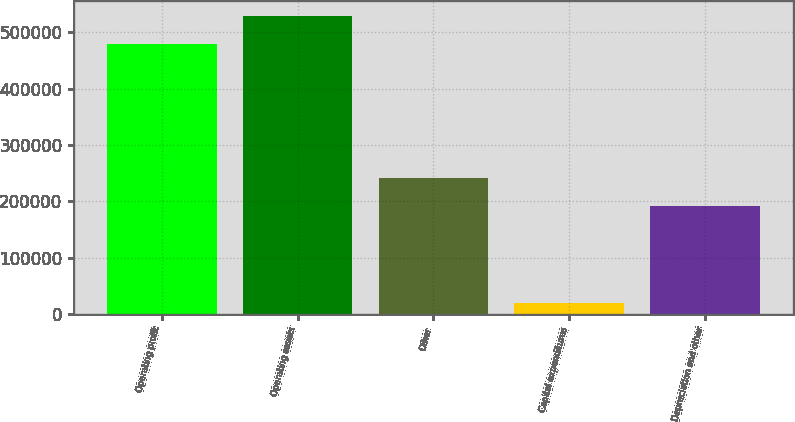Convert chart. <chart><loc_0><loc_0><loc_500><loc_500><bar_chart><fcel>Operating profit<fcel>Operating assets<fcel>Other<fcel>Capital expenditures<fcel>Depreciation and other<nl><fcel>479295<fcel>529129<fcel>241710<fcel>20079<fcel>191876<nl></chart> 